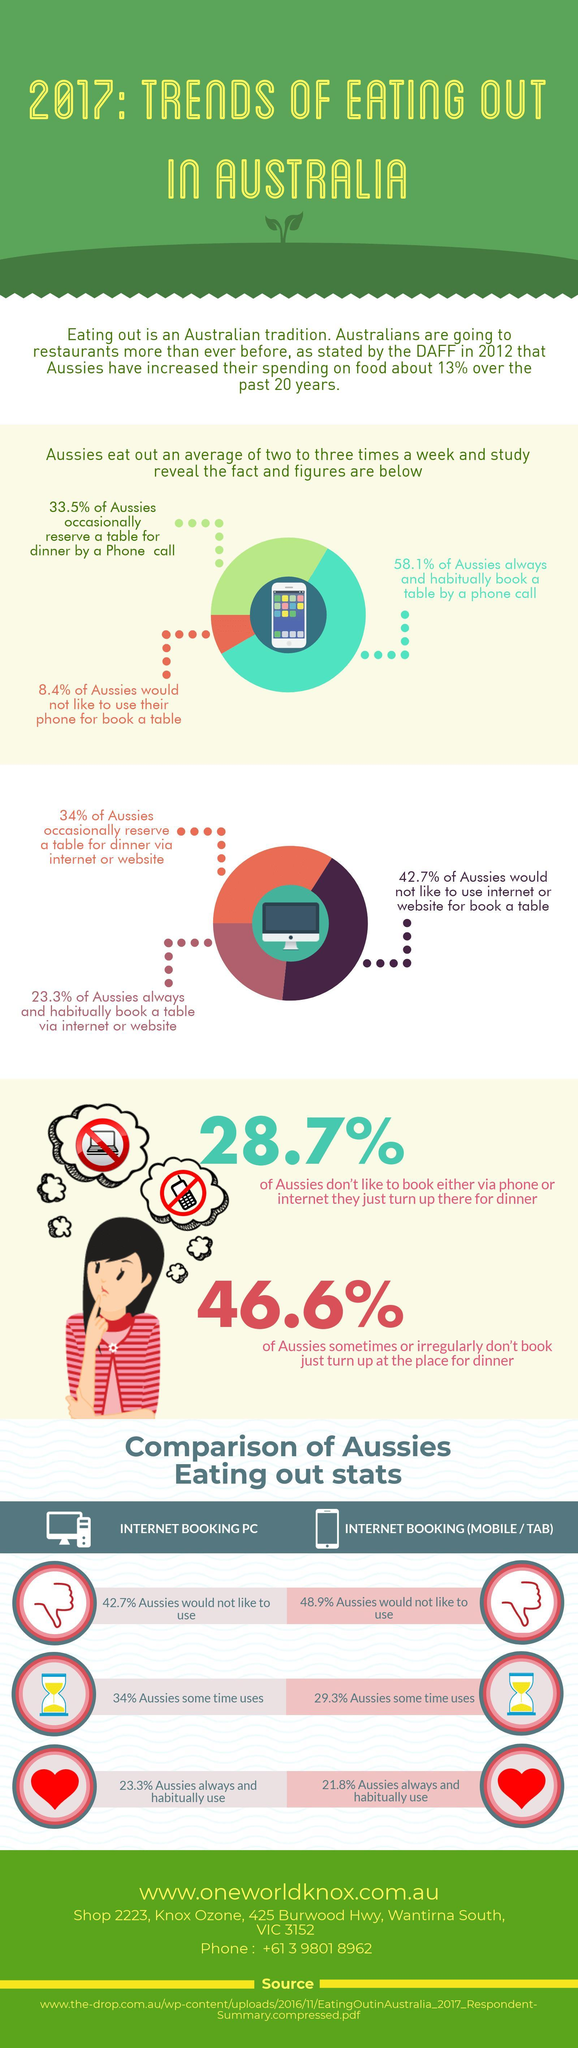34% Aussies sometime uses what?
Answer the question with a short phrase. internet booking PC How many % of Aussies would not like to use Internet booking (mobile / tab) 48.9% What % of Aussies either occasionally or always and habitually book a table by a phone call 91.6 What % of Aussies either occasionally or always and habitually reserve a table for dinner via internet or wesite 57.3 What is the colour of the hear, red or orange red 21.8% Aussies always and habitually use what internet booking (mobile / tab) 